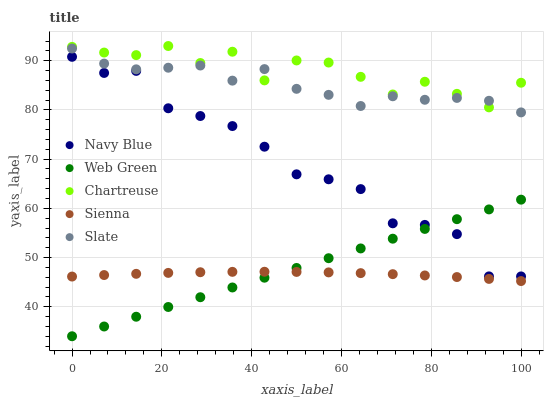Does Sienna have the minimum area under the curve?
Answer yes or no. Yes. Does Chartreuse have the maximum area under the curve?
Answer yes or no. Yes. Does Navy Blue have the minimum area under the curve?
Answer yes or no. No. Does Navy Blue have the maximum area under the curve?
Answer yes or no. No. Is Web Green the smoothest?
Answer yes or no. Yes. Is Chartreuse the roughest?
Answer yes or no. Yes. Is Navy Blue the smoothest?
Answer yes or no. No. Is Navy Blue the roughest?
Answer yes or no. No. Does Web Green have the lowest value?
Answer yes or no. Yes. Does Navy Blue have the lowest value?
Answer yes or no. No. Does Chartreuse have the highest value?
Answer yes or no. Yes. Does Navy Blue have the highest value?
Answer yes or no. No. Is Navy Blue less than Chartreuse?
Answer yes or no. Yes. Is Chartreuse greater than Sienna?
Answer yes or no. Yes. Does Sienna intersect Web Green?
Answer yes or no. Yes. Is Sienna less than Web Green?
Answer yes or no. No. Is Sienna greater than Web Green?
Answer yes or no. No. Does Navy Blue intersect Chartreuse?
Answer yes or no. No. 